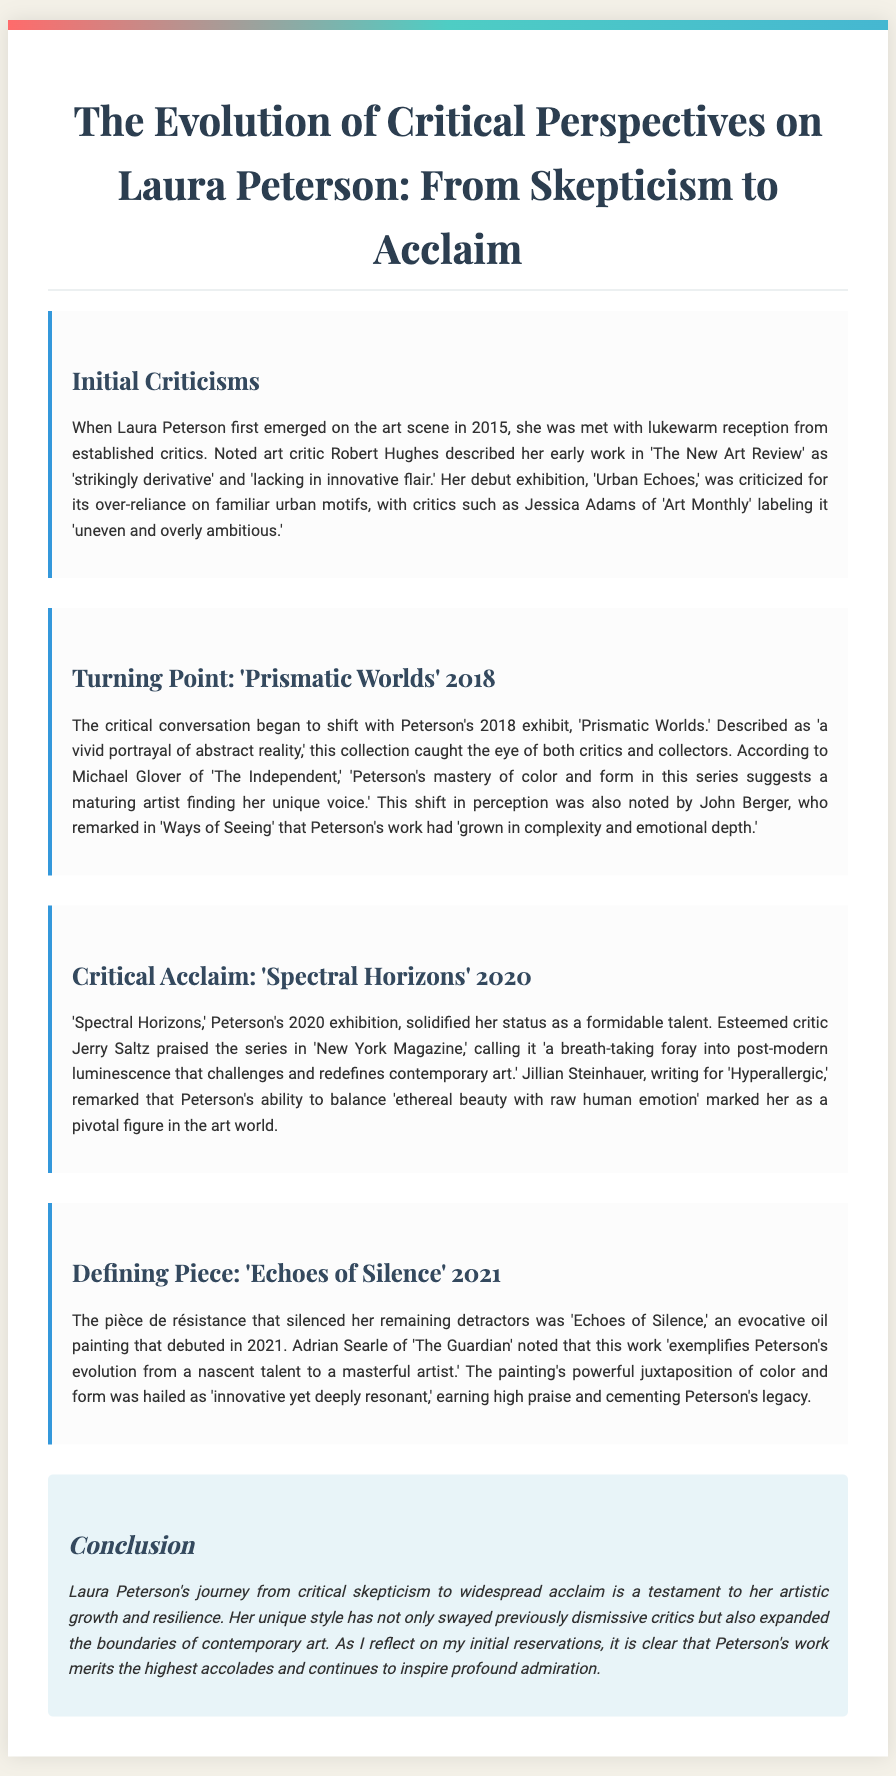What was the title of Laura Peterson's debut exhibition? The title of her debut exhibition was 'Urban Echoes.'
Answer: 'Urban Echoes' Who described Peterson's early work as 'strikingly derivative'? Robert Hughes described her early work as 'strikingly derivative.'
Answer: Robert Hughes In what year did the exhibit 'Prismatic Worlds' occur? The exhibit 'Prismatic Worlds' occurred in 2018.
Answer: 2018 Which critic called 'Spectral Horizons' a 'breath-taking foray into post-modern luminescence'? Jerry Saltz called 'Spectral Horizons' a 'breath-taking foray into post-modern luminescence.'
Answer: Jerry Saltz What is the defining piece that silenced Laura Peterson's remaining detractors? The defining piece is 'Echoes of Silence.'
Answer: 'Echoes of Silence' How did Laura Peterson's artistic journey change over time according to the document? The document describes her journey as evolving from critical skepticism to widespread acclaim.
Answer: From skepticism to acclaim Which exhibition marked a turning point in the critical conversation about Peterson's work? The exhibition that marked a turning point was 'Prismatic Worlds.'
Answer: 'Prismatic Worlds' What does the conclusion state about Peterson's work's impact on critics? The conclusion states it swayed previously dismissive critics.
Answer: Swayed critics 